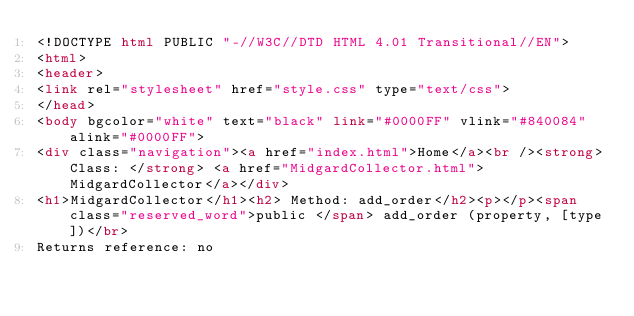Convert code to text. <code><loc_0><loc_0><loc_500><loc_500><_HTML_><!DOCTYPE html PUBLIC "-//W3C//DTD HTML 4.01 Transitional//EN">
<html>
<header> 
<link rel="stylesheet" href="style.css" type="text/css">
</head>
<body bgcolor="white" text="black" link="#0000FF" vlink="#840084" alink="#0000FF">
<div class="navigation"><a href="index.html">Home</a><br /><strong>Class: </strong> <a href="MidgardCollector.html">MidgardCollector</a></div>
<h1>MidgardCollector</h1><h2> Method: add_order</h2><p></p><span class="reserved_word">public </span> add_order (property, [type])</br>
Returns reference: no</code> 